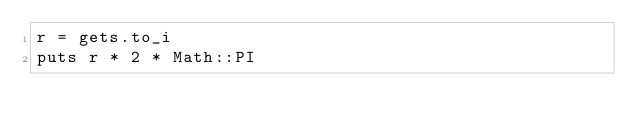Convert code to text. <code><loc_0><loc_0><loc_500><loc_500><_Ruby_>r = gets.to_i
puts r * 2 * Math::PI</code> 